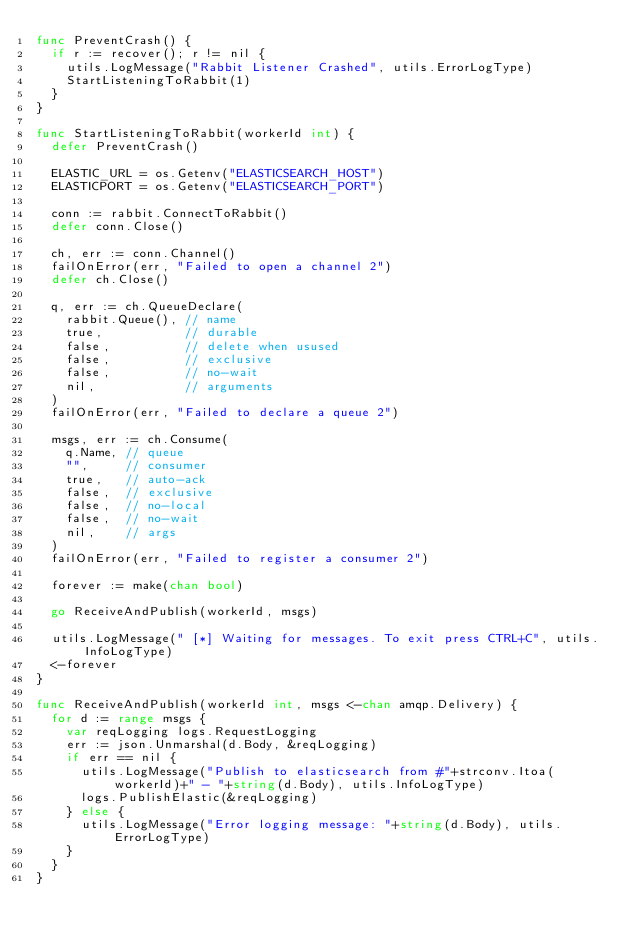<code> <loc_0><loc_0><loc_500><loc_500><_Go_>func PreventCrash() {
	if r := recover(); r != nil {
		utils.LogMessage("Rabbit Listener Crashed", utils.ErrorLogType)
		StartListeningToRabbit(1)
	}
}

func StartListeningToRabbit(workerId int) {
	defer PreventCrash()

	ELASTIC_URL = os.Getenv("ELASTICSEARCH_HOST")
	ELASTICPORT = os.Getenv("ELASTICSEARCH_PORT")

	conn := rabbit.ConnectToRabbit()
	defer conn.Close()

	ch, err := conn.Channel()
	failOnError(err, "Failed to open a channel 2")
	defer ch.Close()

	q, err := ch.QueueDeclare(
		rabbit.Queue(), // name
		true,           // durable
		false,          // delete when usused
		false,          // exclusive
		false,          // no-wait
		nil,            // arguments
	)
	failOnError(err, "Failed to declare a queue 2")

	msgs, err := ch.Consume(
		q.Name, // queue
		"",     // consumer
		true,   // auto-ack
		false,  // exclusive
		false,  // no-local
		false,  // no-wait
		nil,    // args
	)
	failOnError(err, "Failed to register a consumer 2")

	forever := make(chan bool)

	go ReceiveAndPublish(workerId, msgs)

	utils.LogMessage(" [*] Waiting for messages. To exit press CTRL+C", utils.InfoLogType)
	<-forever
}

func ReceiveAndPublish(workerId int, msgs <-chan amqp.Delivery) {
	for d := range msgs {
		var reqLogging logs.RequestLogging
		err := json.Unmarshal(d.Body, &reqLogging)
		if err == nil {
			utils.LogMessage("Publish to elasticsearch from #"+strconv.Itoa(workerId)+" - "+string(d.Body), utils.InfoLogType)
			logs.PublishElastic(&reqLogging)
		} else {
			utils.LogMessage("Error logging message: "+string(d.Body), utils.ErrorLogType)
		}
	}
}
</code> 